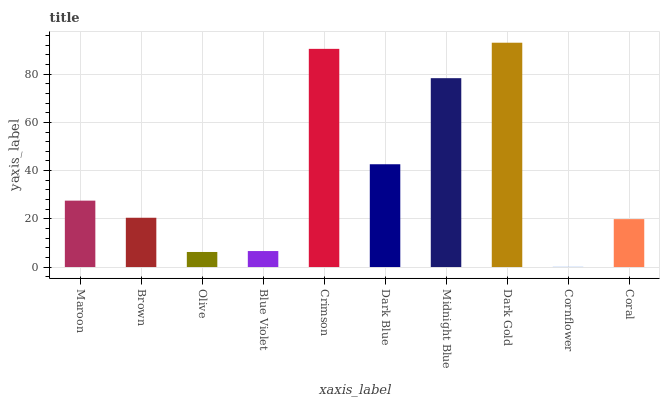Is Cornflower the minimum?
Answer yes or no. Yes. Is Dark Gold the maximum?
Answer yes or no. Yes. Is Brown the minimum?
Answer yes or no. No. Is Brown the maximum?
Answer yes or no. No. Is Maroon greater than Brown?
Answer yes or no. Yes. Is Brown less than Maroon?
Answer yes or no. Yes. Is Brown greater than Maroon?
Answer yes or no. No. Is Maroon less than Brown?
Answer yes or no. No. Is Maroon the high median?
Answer yes or no. Yes. Is Brown the low median?
Answer yes or no. Yes. Is Crimson the high median?
Answer yes or no. No. Is Olive the low median?
Answer yes or no. No. 